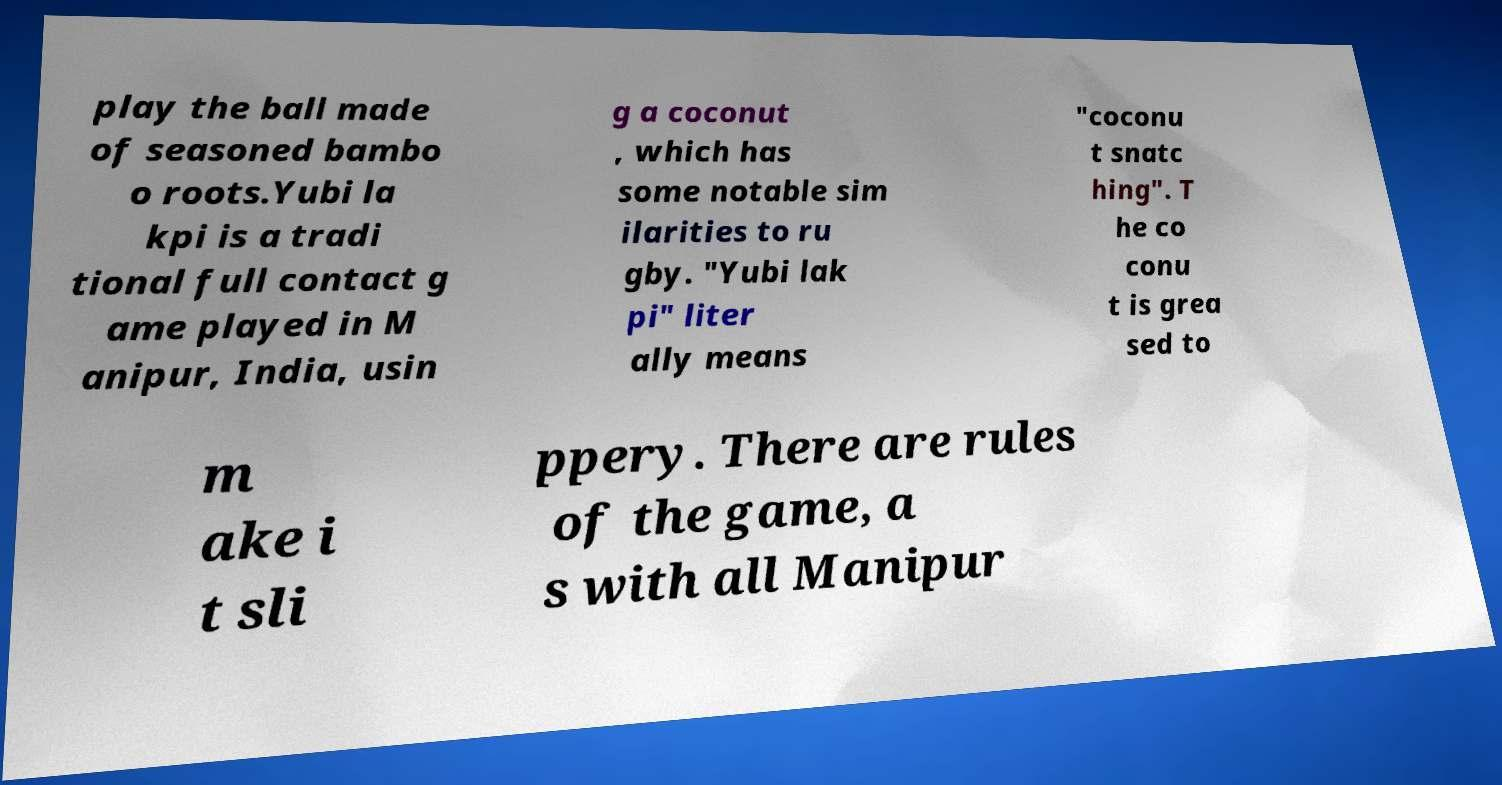Can you read and provide the text displayed in the image?This photo seems to have some interesting text. Can you extract and type it out for me? play the ball made of seasoned bambo o roots.Yubi la kpi is a tradi tional full contact g ame played in M anipur, India, usin g a coconut , which has some notable sim ilarities to ru gby. "Yubi lak pi" liter ally means "coconu t snatc hing". T he co conu t is grea sed to m ake i t sli ppery. There are rules of the game, a s with all Manipur 